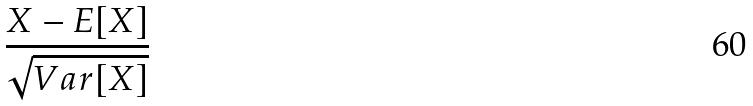<formula> <loc_0><loc_0><loc_500><loc_500>\frac { X - E [ X ] } { \sqrt { V a r [ X ] } }</formula> 